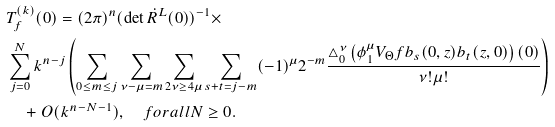Convert formula to latex. <formula><loc_0><loc_0><loc_500><loc_500>& T ^ { ( k ) } _ { f } ( 0 ) = ( 2 \pi ) ^ { n } ( \det \dot { R } ^ { L } ( 0 ) ) ^ { - 1 } \times \\ & \sum ^ { N } _ { j = 0 } k ^ { n - j } \left ( \sum _ { 0 \leq m \leq j } \sum _ { \nu - \mu = m } \sum _ { 2 \nu \geq 4 \mu } \sum _ { s + t = j - m } ( - 1 ) ^ { \mu } 2 ^ { - m } \frac { \triangle _ { 0 } ^ { \nu } \left ( \phi _ { 1 } ^ { \mu } V _ { \Theta } f b _ { s } ( 0 , z ) b _ { t } ( z , 0 ) \right ) ( 0 ) } { \nu ! \mu ! } \right ) \\ & \quad + O ( k ^ { n - N - 1 } ) , \quad f o r a l l N \geq 0 .</formula> 